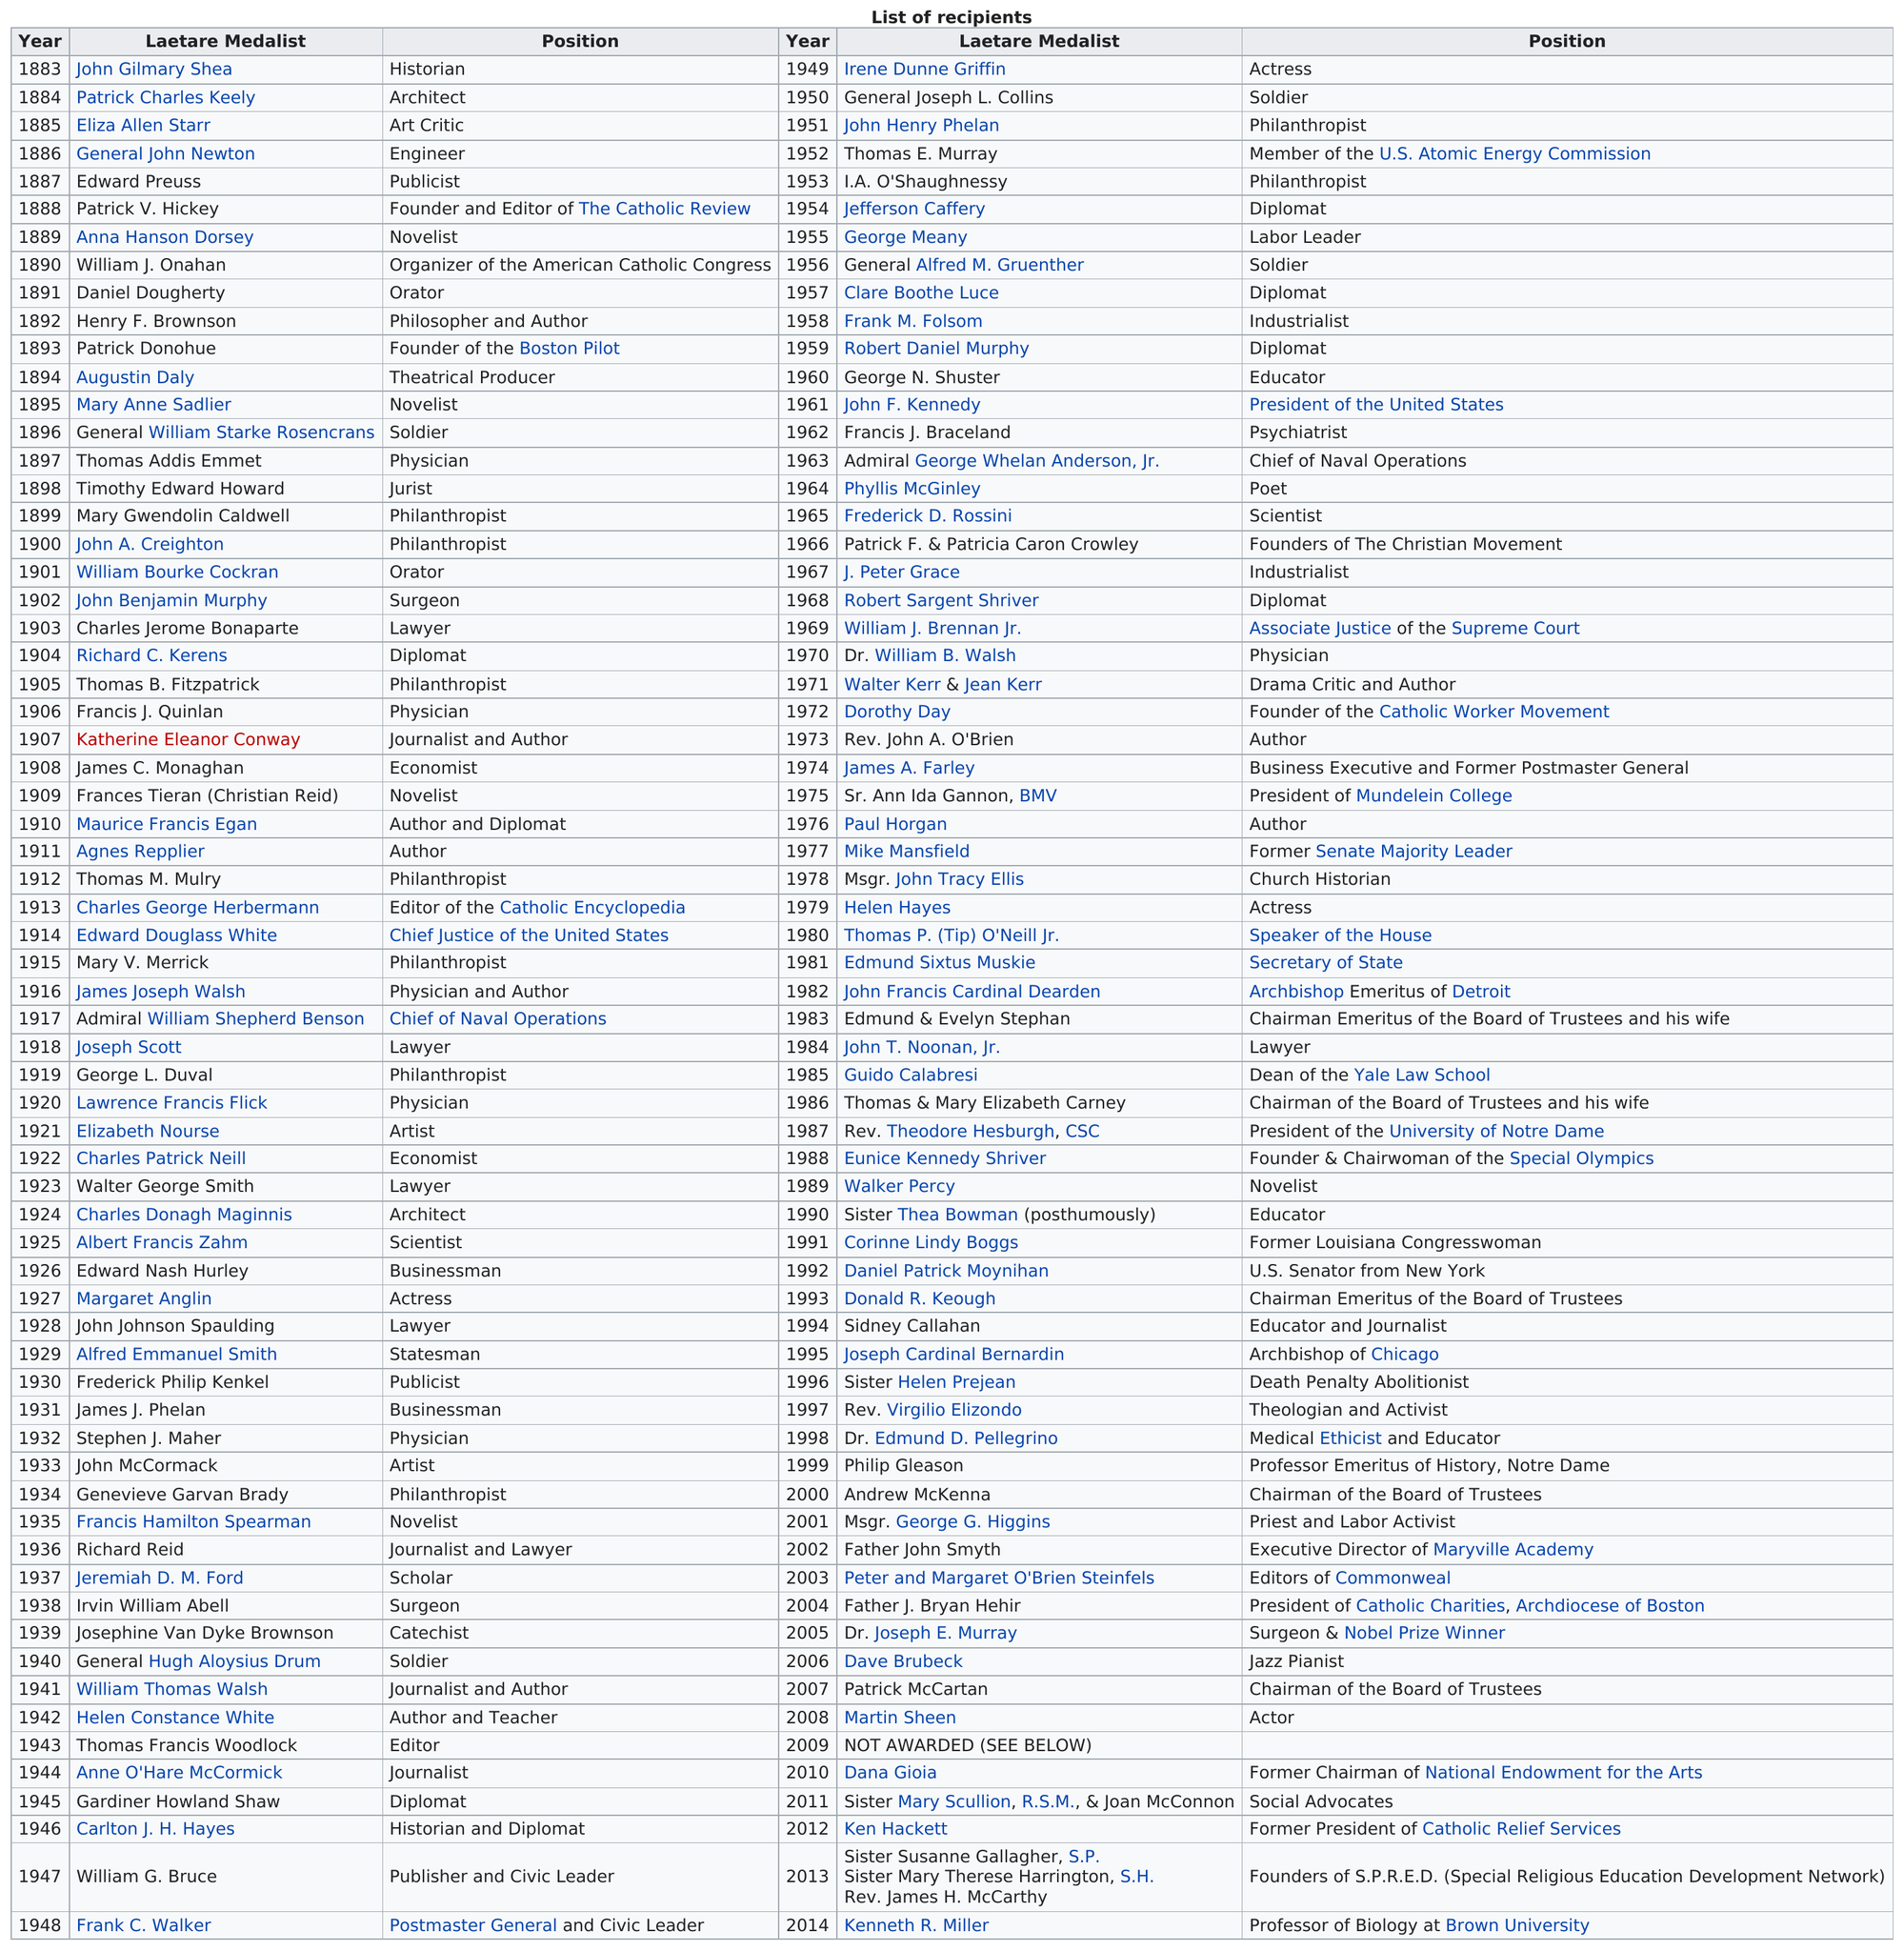Draw attention to some important aspects in this diagram. The chart shows that the word 'philanthropist' appears in the 'position' column 9 times. Dr. Joseph E. Murray has won both the Nobel Prize and the Presidential Medal of Freedom. Thomas B. Fitzpatrick won in 1905, and Thomas M. Mulry was the next philanthropist to win in 1905. Out of the two Laetare Medalists who were philanthropists, one was a known philanthropist. The chart shows the position of soldiers, and there are a total of 4 instances where the soldier is listed as the position. 